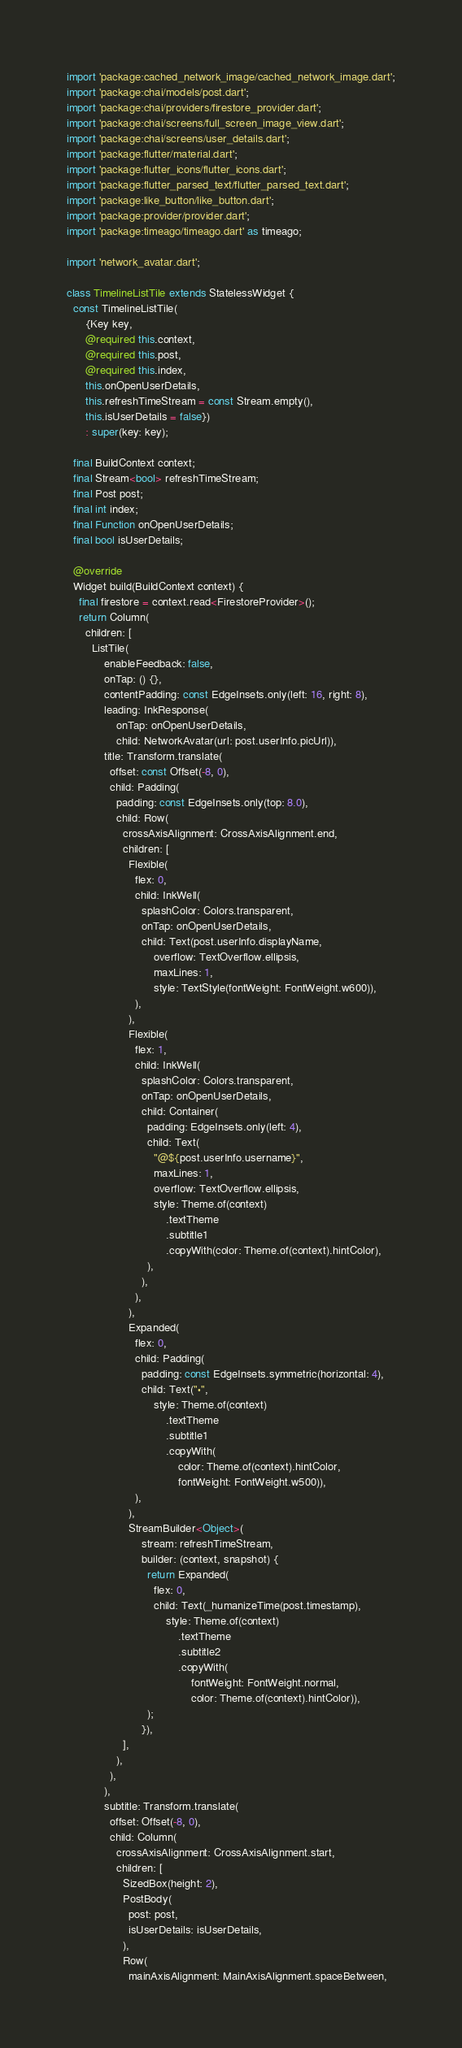Convert code to text. <code><loc_0><loc_0><loc_500><loc_500><_Dart_>import 'package:cached_network_image/cached_network_image.dart';
import 'package:chai/models/post.dart';
import 'package:chai/providers/firestore_provider.dart';
import 'package:chai/screens/full_screen_image_view.dart';
import 'package:chai/screens/user_details.dart';
import 'package:flutter/material.dart';
import 'package:flutter_icons/flutter_icons.dart';
import 'package:flutter_parsed_text/flutter_parsed_text.dart';
import 'package:like_button/like_button.dart';
import 'package:provider/provider.dart';
import 'package:timeago/timeago.dart' as timeago;

import 'network_avatar.dart';

class TimelineListTile extends StatelessWidget {
  const TimelineListTile(
      {Key key,
      @required this.context,
      @required this.post,
      @required this.index,
      this.onOpenUserDetails,
      this.refreshTimeStream = const Stream.empty(),
      this.isUserDetails = false})
      : super(key: key);

  final BuildContext context;
  final Stream<bool> refreshTimeStream;
  final Post post;
  final int index;
  final Function onOpenUserDetails;
  final bool isUserDetails;

  @override
  Widget build(BuildContext context) {
    final firestore = context.read<FirestoreProvider>();
    return Column(
      children: [
        ListTile(
            enableFeedback: false,
            onTap: () {},
            contentPadding: const EdgeInsets.only(left: 16, right: 8),
            leading: InkResponse(
                onTap: onOpenUserDetails,
                child: NetworkAvatar(url: post.userInfo.picUrl)),
            title: Transform.translate(
              offset: const Offset(-8, 0),
              child: Padding(
                padding: const EdgeInsets.only(top: 8.0),
                child: Row(
                  crossAxisAlignment: CrossAxisAlignment.end,
                  children: [
                    Flexible(
                      flex: 0,
                      child: InkWell(
                        splashColor: Colors.transparent,
                        onTap: onOpenUserDetails,
                        child: Text(post.userInfo.displayName,
                            overflow: TextOverflow.ellipsis,
                            maxLines: 1,
                            style: TextStyle(fontWeight: FontWeight.w600)),
                      ),
                    ),
                    Flexible(
                      flex: 1,
                      child: InkWell(
                        splashColor: Colors.transparent,
                        onTap: onOpenUserDetails,
                        child: Container(
                          padding: EdgeInsets.only(left: 4),
                          child: Text(
                            "@${post.userInfo.username}",
                            maxLines: 1,
                            overflow: TextOverflow.ellipsis,
                            style: Theme.of(context)
                                .textTheme
                                .subtitle1
                                .copyWith(color: Theme.of(context).hintColor),
                          ),
                        ),
                      ),
                    ),
                    Expanded(
                      flex: 0,
                      child: Padding(
                        padding: const EdgeInsets.symmetric(horizontal: 4),
                        child: Text("·",
                            style: Theme.of(context)
                                .textTheme
                                .subtitle1
                                .copyWith(
                                    color: Theme.of(context).hintColor,
                                    fontWeight: FontWeight.w500)),
                      ),
                    ),
                    StreamBuilder<Object>(
                        stream: refreshTimeStream,
                        builder: (context, snapshot) {
                          return Expanded(
                            flex: 0,
                            child: Text(_humanizeTime(post.timestamp),
                                style: Theme.of(context)
                                    .textTheme
                                    .subtitle2
                                    .copyWith(
                                        fontWeight: FontWeight.normal,
                                        color: Theme.of(context).hintColor)),
                          );
                        }),
                  ],
                ),
              ),
            ),
            subtitle: Transform.translate(
              offset: Offset(-8, 0),
              child: Column(
                crossAxisAlignment: CrossAxisAlignment.start,
                children: [
                  SizedBox(height: 2),
                  PostBody(
                    post: post,
                    isUserDetails: isUserDetails,
                  ),
                  Row(
                    mainAxisAlignment: MainAxisAlignment.spaceBetween,</code> 